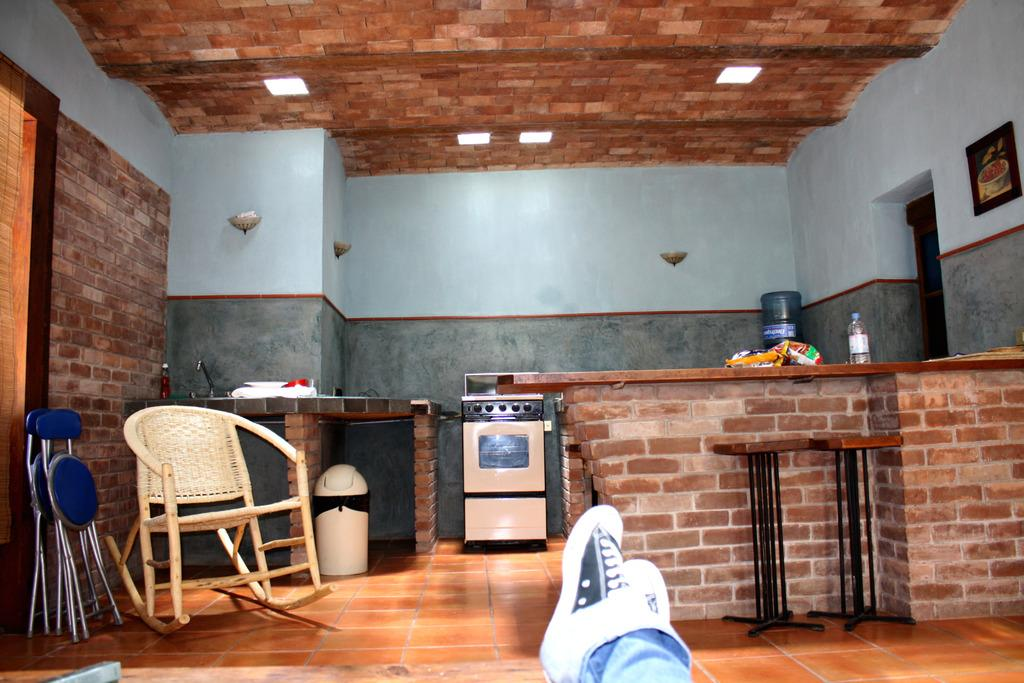What type of space is shown in the image? The image depicts the interior of a room. What furniture is present in the room? There are chairs in the room. What is used for waste disposal in the room? There is a dustbin in the room. What appliance is present in the room for cooking or baking? There is an oven in the room. What type of containers can be seen in the room? There are bottles in the room. Is there a person present in the room? Yes, there is a person in the room. What type of letter is being written by the person in the room? There is no indication in the image that the person is writing a letter. What type of bulb is hanging from the ceiling in the room? There is no bulb visible in the image; only the presence of a person, chairs, a dustbin, an oven, and bottles is mentioned. 